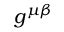Convert formula to latex. <formula><loc_0><loc_0><loc_500><loc_500>g ^ { \mu \beta }</formula> 